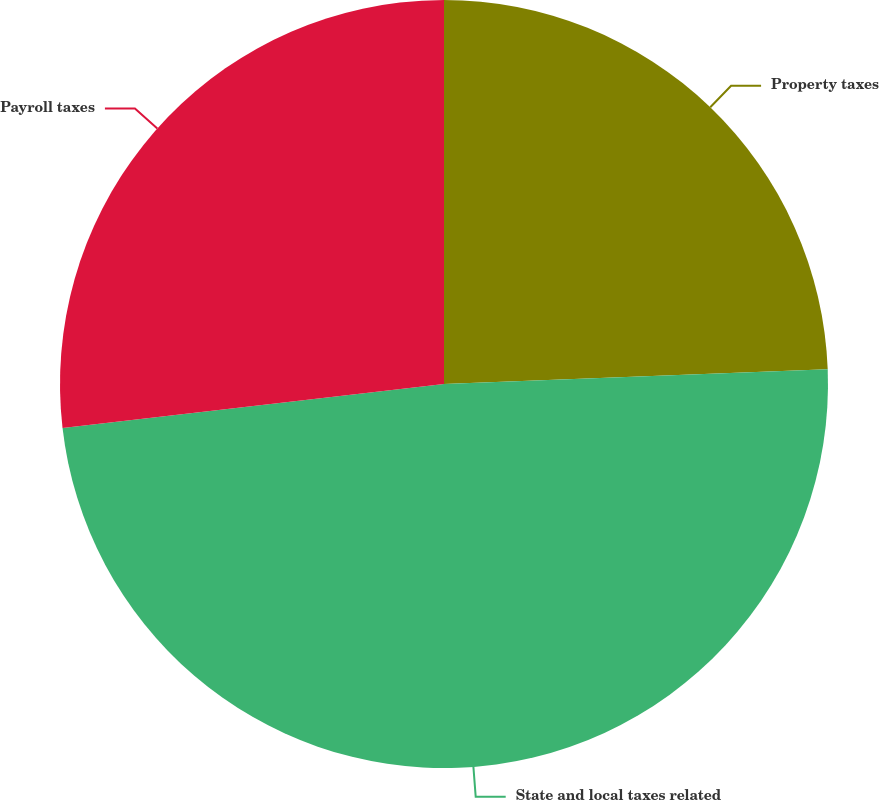Convert chart. <chart><loc_0><loc_0><loc_500><loc_500><pie_chart><fcel>Property taxes<fcel>State and local taxes related<fcel>Payroll taxes<nl><fcel>24.39%<fcel>48.78%<fcel>26.83%<nl></chart> 